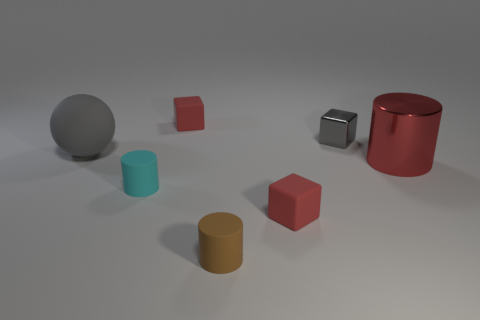Add 1 brown things. How many objects exist? 8 Subtract all spheres. How many objects are left? 6 Subtract all tiny gray metal blocks. Subtract all red cubes. How many objects are left? 4 Add 7 large matte things. How many large matte things are left? 8 Add 6 blue matte cylinders. How many blue matte cylinders exist? 6 Subtract 0 brown blocks. How many objects are left? 7 